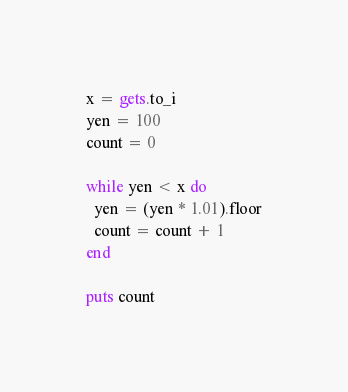Convert code to text. <code><loc_0><loc_0><loc_500><loc_500><_Ruby_>x = gets.to_i
yen = 100
count = 0
 
while yen < x do
  yen = (yen * 1.01).floor
  count = count + 1
end
 
puts count</code> 